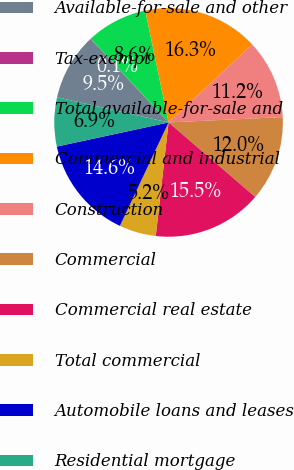Convert chart. <chart><loc_0><loc_0><loc_500><loc_500><pie_chart><fcel>Available-for-sale and other<fcel>Tax-exempt<fcel>Total available-for-sale and<fcel>Commercial and industrial<fcel>Construction<fcel>Commercial<fcel>Commercial real estate<fcel>Total commercial<fcel>Automobile loans and leases<fcel>Residential mortgage<nl><fcel>9.49%<fcel>0.08%<fcel>8.63%<fcel>16.33%<fcel>11.2%<fcel>12.05%<fcel>15.48%<fcel>5.21%<fcel>14.62%<fcel>6.92%<nl></chart> 